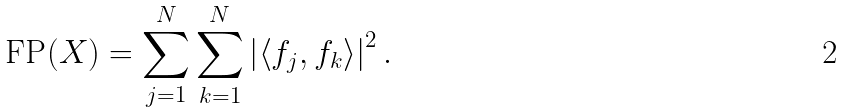Convert formula to latex. <formula><loc_0><loc_0><loc_500><loc_500>\text {FP} ( X ) = \sum _ { j = 1 } ^ { N } \sum _ { k = 1 } ^ { N } \left | \left \langle f _ { j } , f _ { k } \right \rangle \right | ^ { 2 } .</formula> 